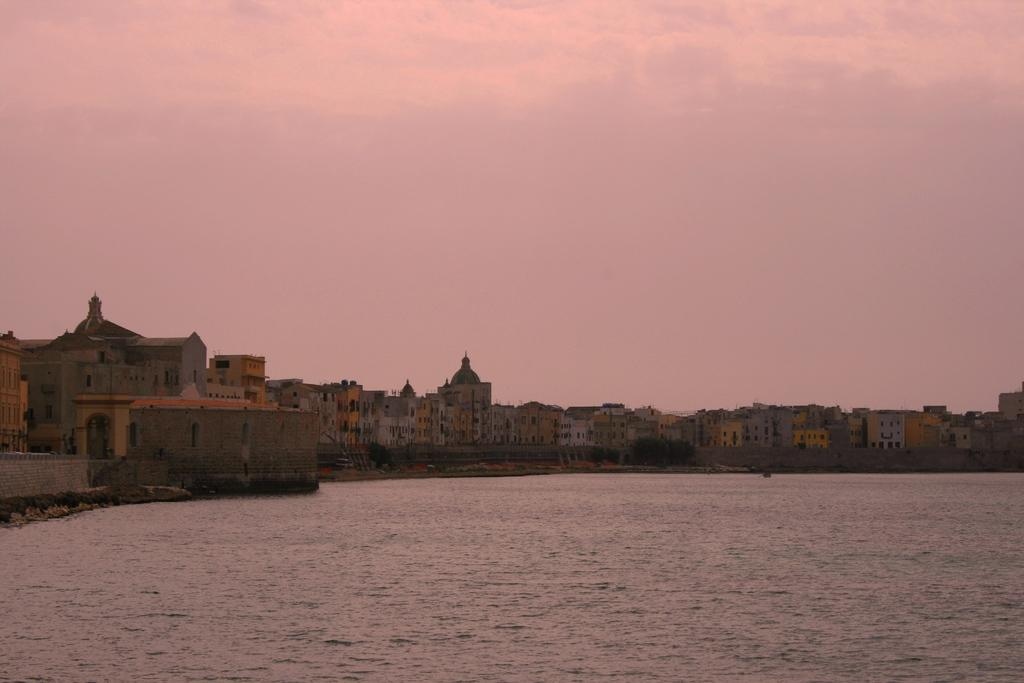What type of natural feature is present in the image? There is a river in the image. What man-made structures can be seen in the image? There are buildings in the image. What part of the natural environment is visible in the image? The sky is visible in the image. What type of celery can be seen growing near the river in the image? There is no celery present in the image. How intense is the rainstorm depicted in the image? There is no rainstorm depicted in the image; it is a clear sky. 